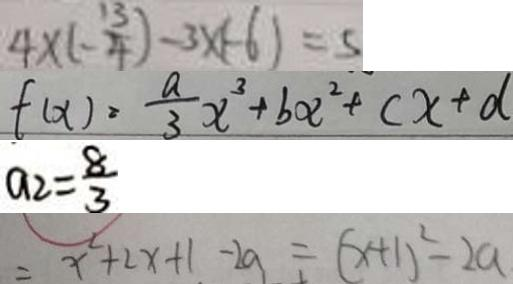<formula> <loc_0><loc_0><loc_500><loc_500>4 \times ( - \frac { 1 3 } { 4 } ) - 3 \times ( - 6 ) = 5 
 f ( x ) = \frac { a } { 3 } x ^ { 3 } + b x ^ { 2 } + c x + d 
 a _ { 2 } = \frac { 8 } { 3 } 
 = x ^ { 2 } + 2 x + 1 - 2 a = ( x + 1 ) ^ { 2 } - 2 a</formula> 